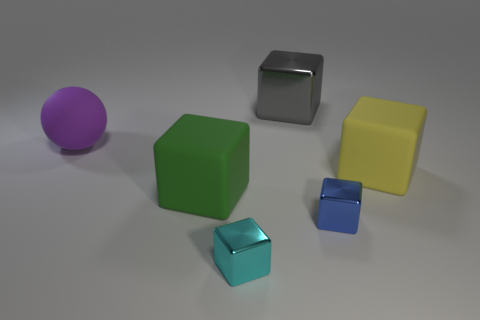There is another metal object that is the same size as the cyan shiny thing; what is its color?
Ensure brevity in your answer.  Blue. What size is the metallic block behind the rubber object that is left of the large green matte thing?
Give a very brief answer. Large. What number of other objects are the same size as the yellow cube?
Your answer should be very brief. 3. How many small yellow metal cylinders are there?
Provide a short and direct response. 0. Is the size of the green object the same as the blue metal block?
Provide a succinct answer. No. How many other objects are the same shape as the large green object?
Ensure brevity in your answer.  4. There is a large thing that is in front of the big matte cube behind the large green cube; what is its material?
Your answer should be compact. Rubber. Are there any gray shiny cubes on the right side of the yellow rubber block?
Provide a succinct answer. No. There is a blue shiny thing; is its size the same as the object on the left side of the large green object?
Keep it short and to the point. No. There is a yellow rubber object that is the same shape as the small cyan shiny thing; what size is it?
Offer a very short reply. Large. 